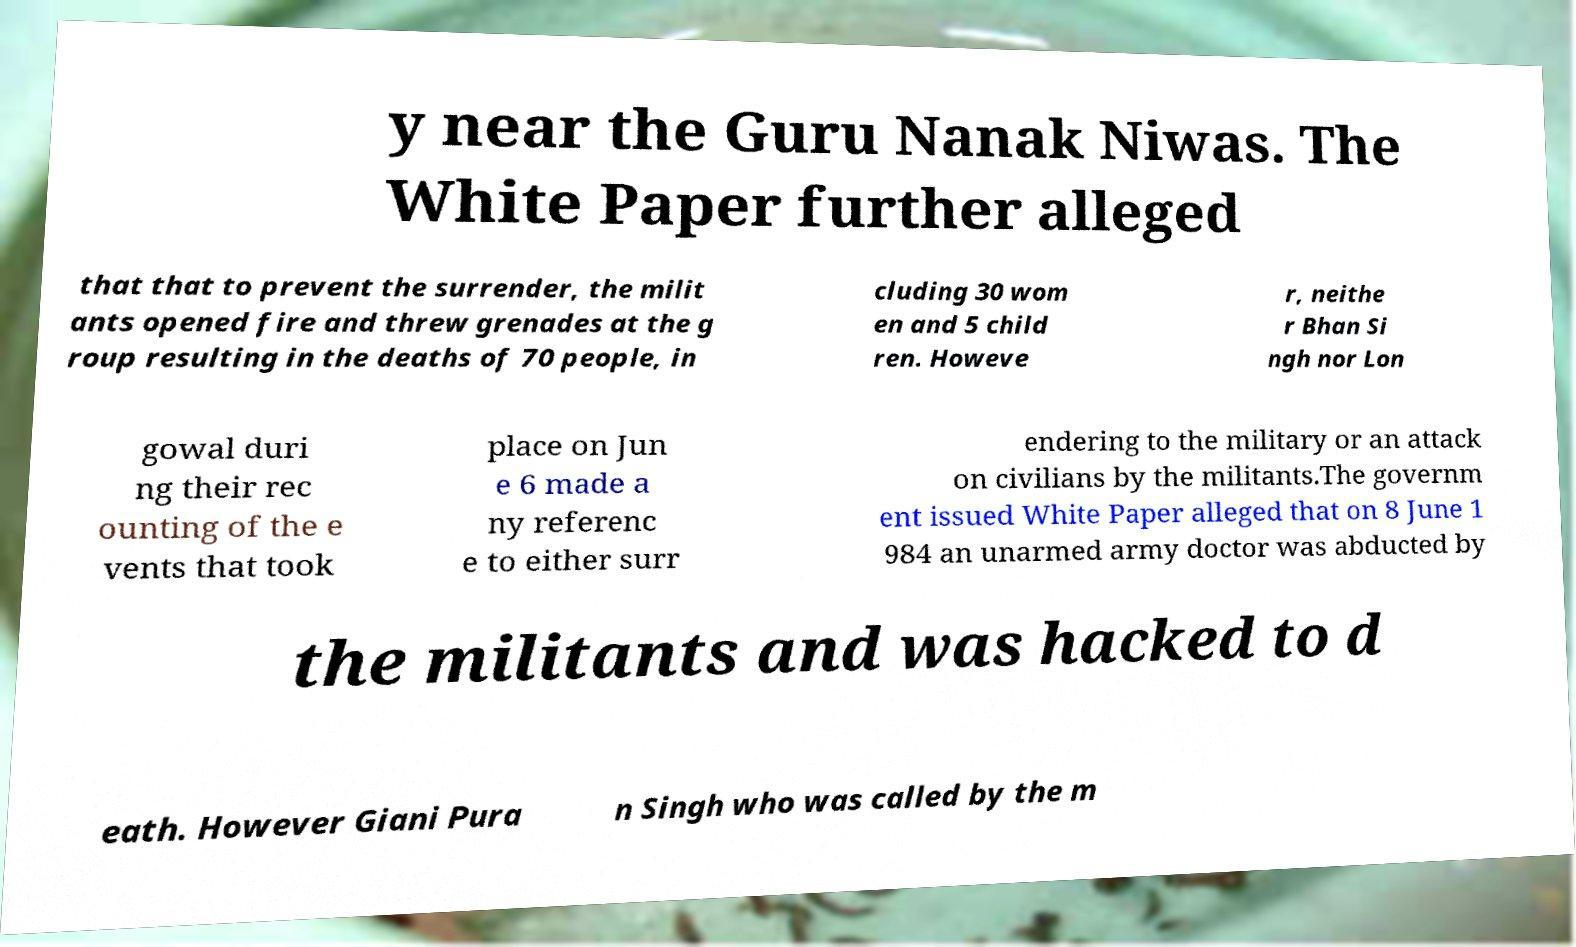For documentation purposes, I need the text within this image transcribed. Could you provide that? y near the Guru Nanak Niwas. The White Paper further alleged that that to prevent the surrender, the milit ants opened fire and threw grenades at the g roup resulting in the deaths of 70 people, in cluding 30 wom en and 5 child ren. Howeve r, neithe r Bhan Si ngh nor Lon gowal duri ng their rec ounting of the e vents that took place on Jun e 6 made a ny referenc e to either surr endering to the military or an attack on civilians by the militants.The governm ent issued White Paper alleged that on 8 June 1 984 an unarmed army doctor was abducted by the militants and was hacked to d eath. However Giani Pura n Singh who was called by the m 